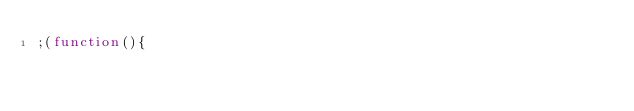<code> <loc_0><loc_0><loc_500><loc_500><_JavaScript_>;(function(){
  </code> 